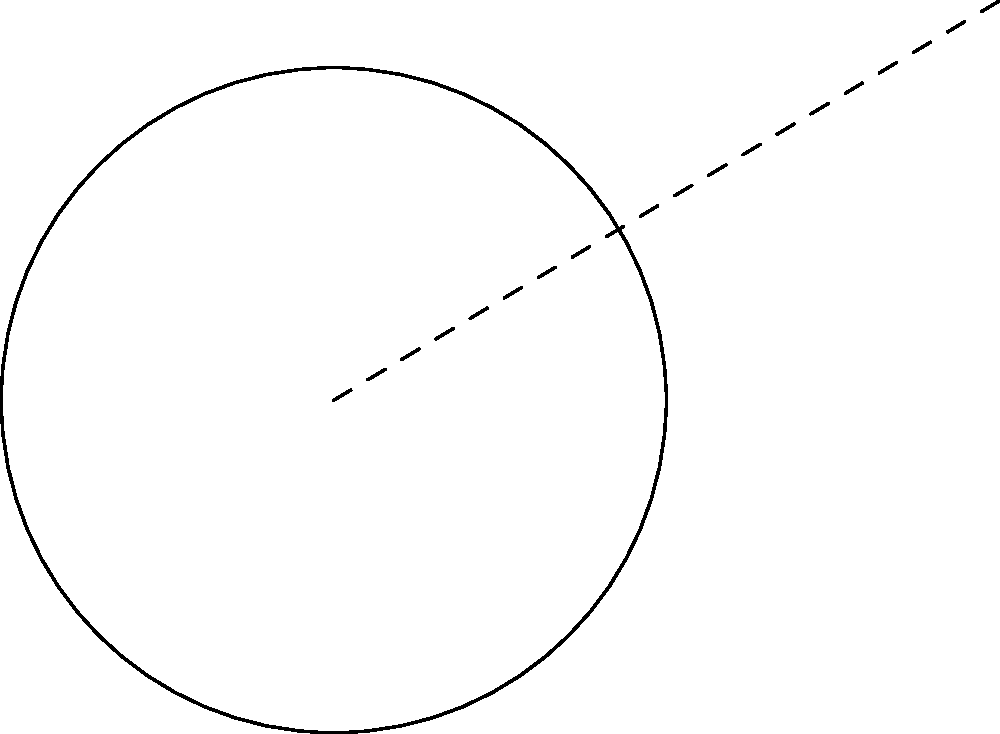In una campagna di comunicazione visiva, si sta progettando un logo circolare con un elemento esterno. Nel diagramma, O è il centro del logo circolare con raggio 2.5 cm, e P è un punto esterno da cui parte un elemento tangente al logo. Se la distanza OP è 5.83 cm, qual è la lunghezza della linea tangente PT? Per risolvere questo problema, seguiamo questi passaggi:

1) In un triangolo rettangolo OPT, dove T è il punto di tangenza:
   - OT è il raggio del cerchio (r = 2.5 cm)
   - OP è la distanza dal centro al punto esterno (5.83 cm)
   - PT è la tangente che vogliamo calcolare

2) Utilizziamo il teorema di Pitagora:
   $$(OP)^2 = (OT)^2 + (PT)^2$$

3) Sostituiamo i valori noti:
   $$5.83^2 = 2.5^2 + (PT)^2$$

4) Calcoliamo:
   $$34.0089 = 6.25 + (PT)^2$$

5) Sottraiamo 6.25 da entrambi i lati:
   $$27.7589 = (PT)^2$$

6) Estraiamo la radice quadrata:
   $$PT = \sqrt{27.7589} \approx 5.27 \text{ cm}$$

Quindi, la lunghezza della linea tangente PT è approssimativamente 5.27 cm.
Answer: 5.27 cm 